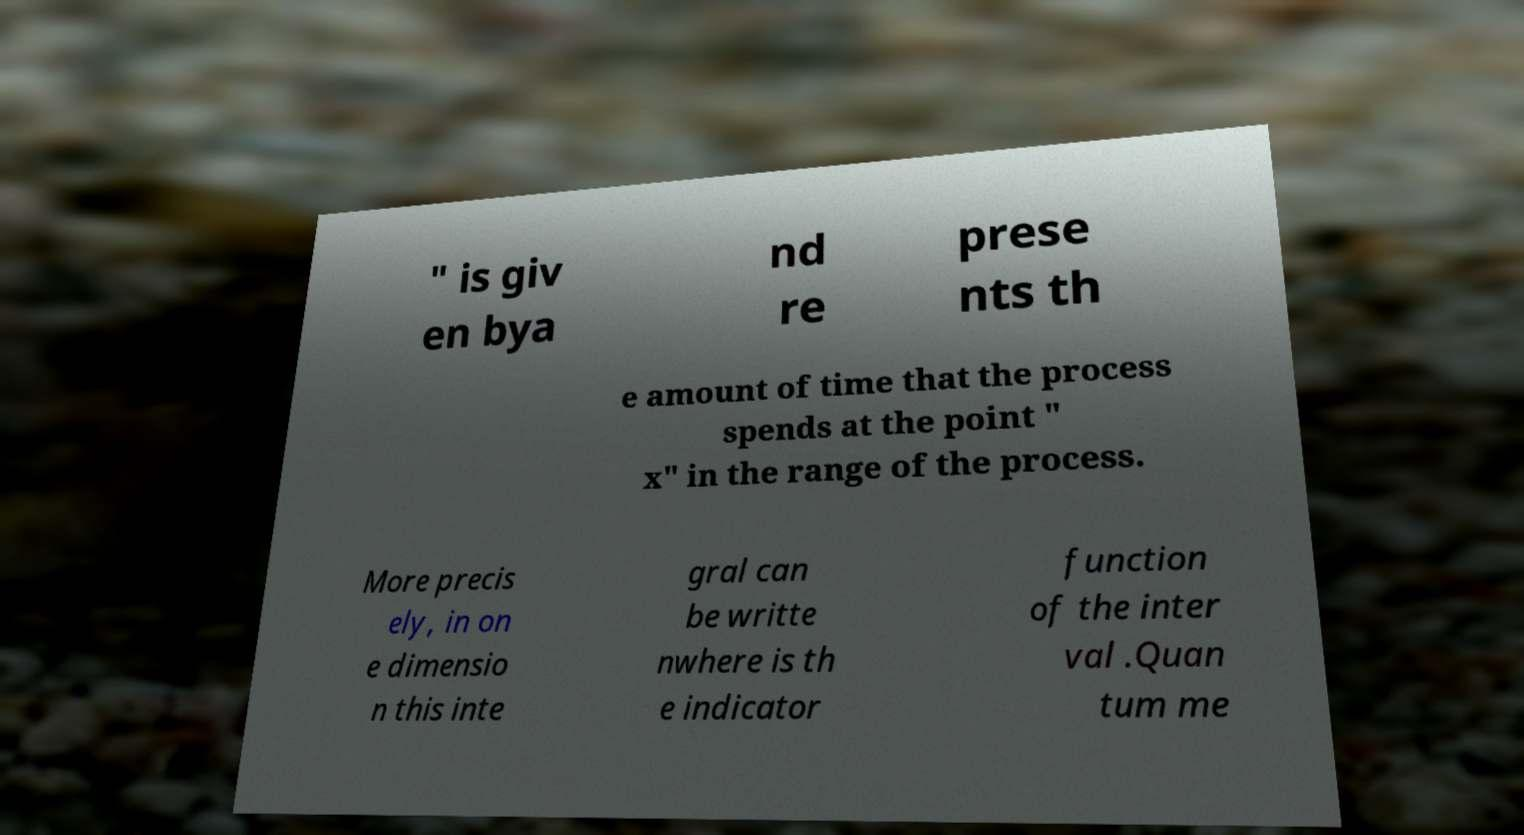Please identify and transcribe the text found in this image. " is giv en bya nd re prese nts th e amount of time that the process spends at the point " x" in the range of the process. More precis ely, in on e dimensio n this inte gral can be writte nwhere is th e indicator function of the inter val .Quan tum me 